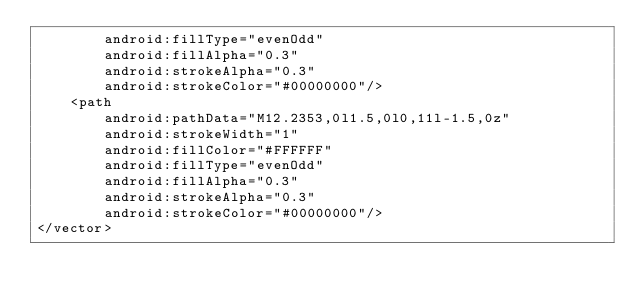Convert code to text. <code><loc_0><loc_0><loc_500><loc_500><_XML_>        android:fillType="evenOdd"
        android:fillAlpha="0.3"
        android:strokeAlpha="0.3"
        android:strokeColor="#00000000"/>
    <path
        android:pathData="M12.2353,0l1.5,0l0,11l-1.5,0z"
        android:strokeWidth="1"
        android:fillColor="#FFFFFF"
        android:fillType="evenOdd"
        android:fillAlpha="0.3"
        android:strokeAlpha="0.3"
        android:strokeColor="#00000000"/>
</vector>
</code> 